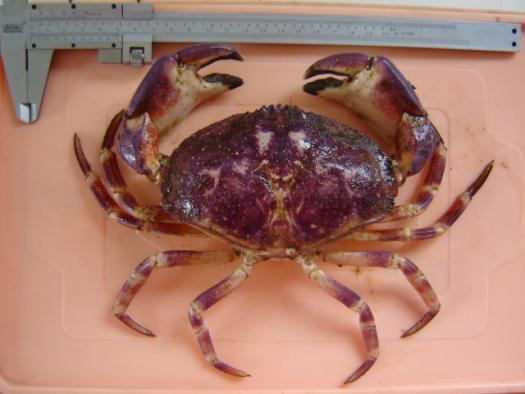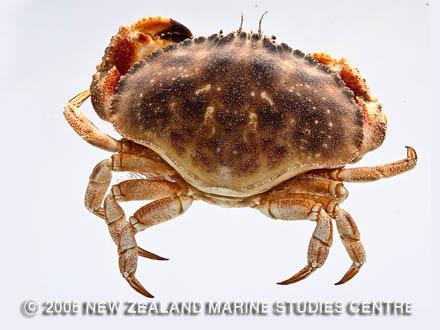The first image is the image on the left, the second image is the image on the right. Analyze the images presented: Is the assertion "Both crabs on the left are a dingy brown color." valid? Answer yes or no. No. The first image is the image on the left, the second image is the image on the right. For the images displayed, is the sentence "There are two whole crabs." factually correct? Answer yes or no. Yes. 